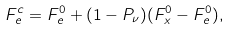<formula> <loc_0><loc_0><loc_500><loc_500>F ^ { c } _ { e } = F ^ { 0 } _ { e } + ( 1 - P _ { \nu } ) ( F ^ { 0 } _ { x } - F ^ { 0 } _ { e } ) ,</formula> 